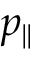Convert formula to latex. <formula><loc_0><loc_0><loc_500><loc_500>p _ { \| }</formula> 